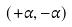<formula> <loc_0><loc_0><loc_500><loc_500>( + \alpha , - \alpha )</formula> 